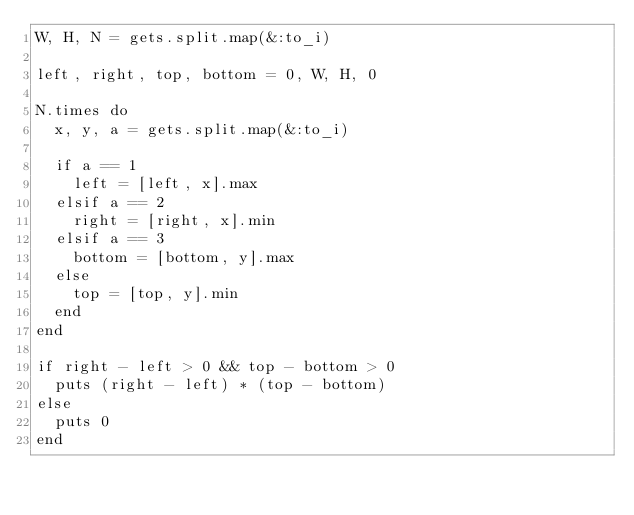<code> <loc_0><loc_0><loc_500><loc_500><_Ruby_>W, H, N = gets.split.map(&:to_i)

left, right, top, bottom = 0, W, H, 0

N.times do
	x, y, a = gets.split.map(&:to_i)
	
	if a == 1
		left = [left, x].max
	elsif a == 2
		right = [right, x].min
	elsif a == 3
		bottom = [bottom, y].max
	else
		top = [top, y].min
	end
end

if right - left > 0 && top - bottom > 0
	puts (right - left) * (top - bottom)
else
	puts 0
end
</code> 